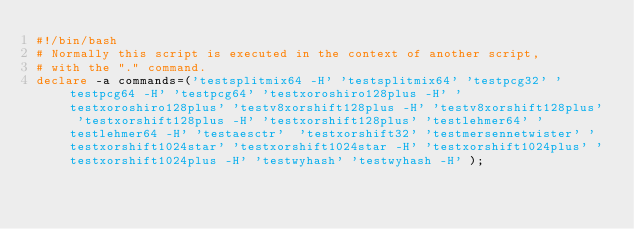<code> <loc_0><loc_0><loc_500><loc_500><_Bash_>#!/bin/bash
# Normally this script is executed in the context of another script,
# with the "." command.
declare -a commands=('testsplitmix64 -H' 'testsplitmix64' 'testpcg32' 'testpcg64 -H' 'testpcg64' 'testxoroshiro128plus -H' 'testxoroshiro128plus' 'testv8xorshift128plus -H' 'testv8xorshift128plus' 'testxorshift128plus -H' 'testxorshift128plus' 'testlehmer64' 'testlehmer64 -H' 'testaesctr'  'testxorshift32' 'testmersennetwister' 'testxorshift1024star' 'testxorshift1024star -H' 'testxorshift1024plus' 'testxorshift1024plus -H' 'testwyhash' 'testwyhash -H' );
</code> 